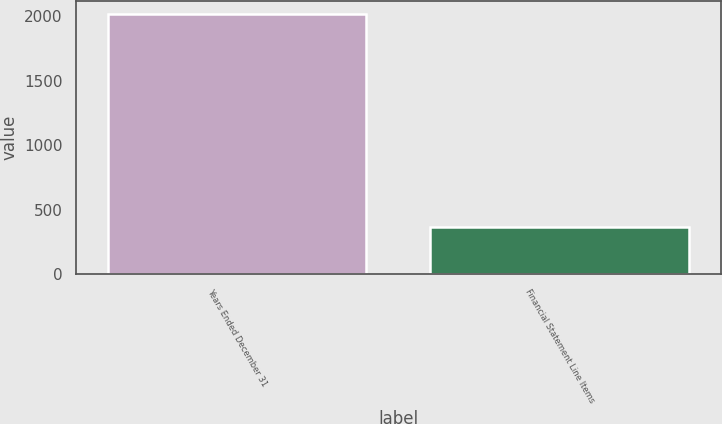<chart> <loc_0><loc_0><loc_500><loc_500><bar_chart><fcel>Years Ended December 31<fcel>Financial Statement Line Items<nl><fcel>2018<fcel>361<nl></chart> 